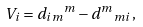Convert formula to latex. <formula><loc_0><loc_0><loc_500><loc_500>V _ { i } = { d _ { i m } } ^ { m } - { d ^ { m } } _ { m i } \, ,</formula> 